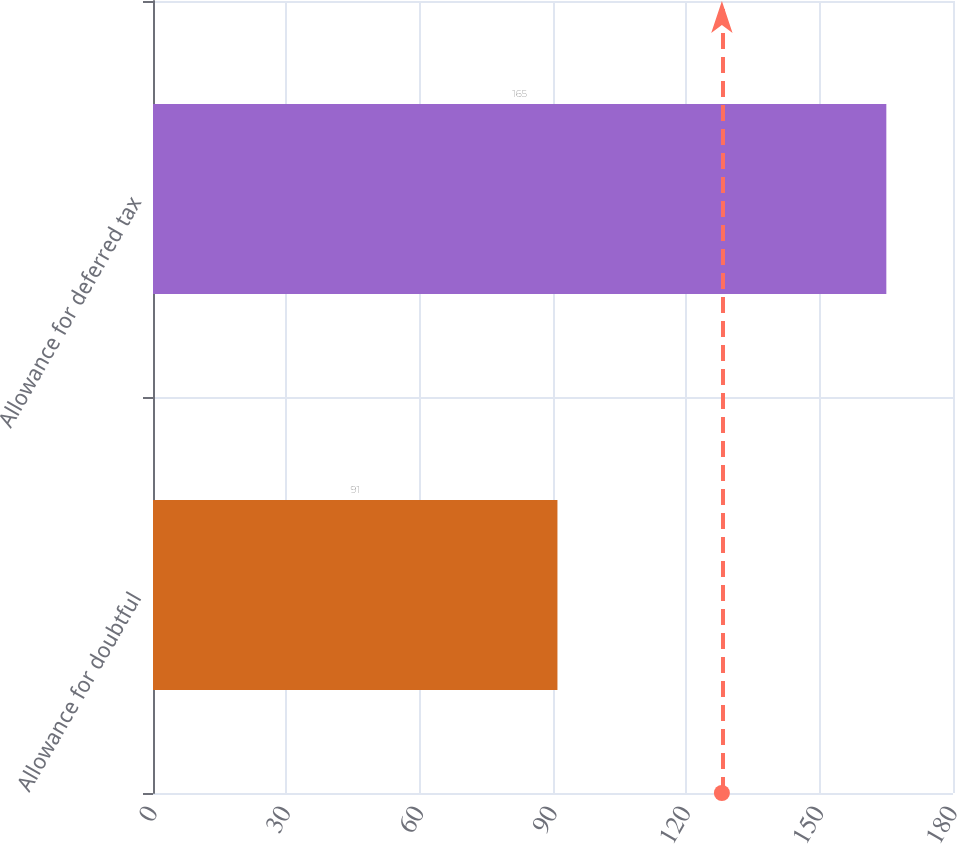Convert chart. <chart><loc_0><loc_0><loc_500><loc_500><bar_chart><fcel>Allowance for doubtful<fcel>Allowance for deferred tax<nl><fcel>91<fcel>165<nl></chart> 